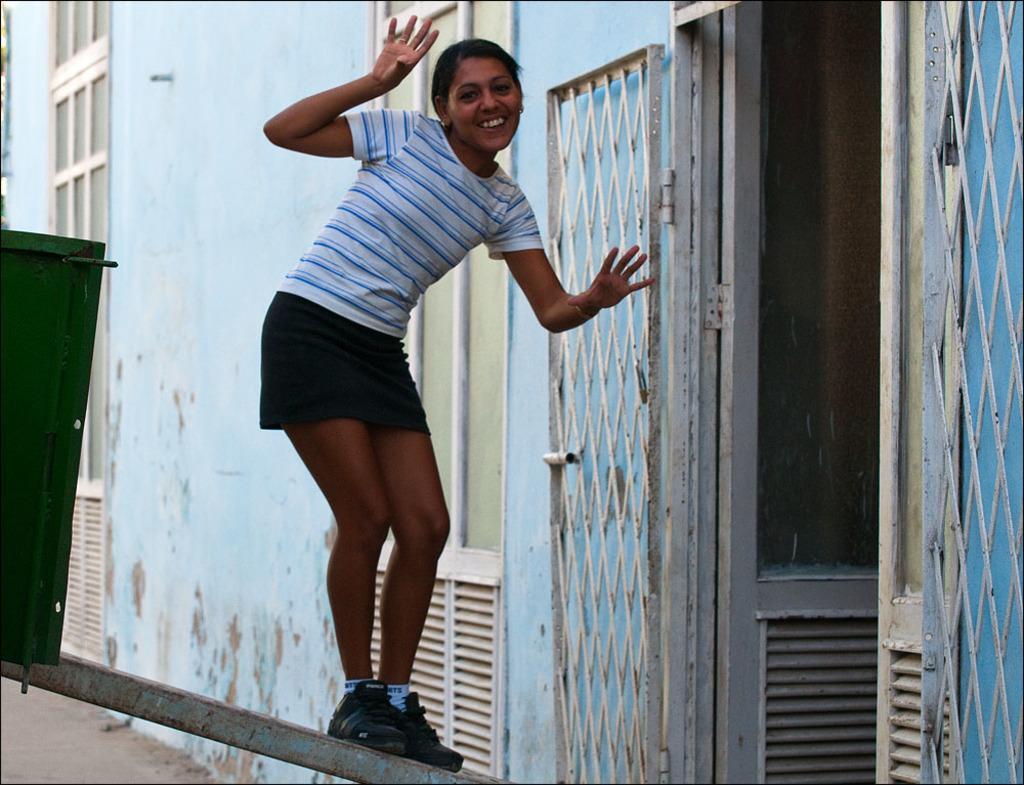Can you describe this image briefly? On the right side of the picture we can see the wall, doors, gate. In this picture we can see a woman wearing a t-shirt and she is standing on the pole. She is smiling. On the left side of the picture we can see green color object. 